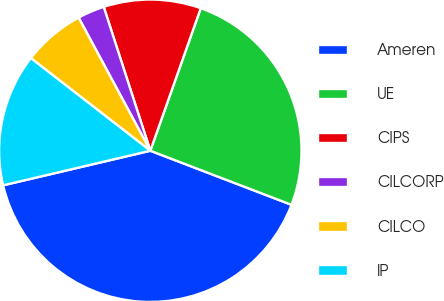Convert chart to OTSL. <chart><loc_0><loc_0><loc_500><loc_500><pie_chart><fcel>Ameren<fcel>UE<fcel>CIPS<fcel>CILCORP<fcel>CILCO<fcel>IP<nl><fcel>40.51%<fcel>25.41%<fcel>10.4%<fcel>2.88%<fcel>6.64%<fcel>14.17%<nl></chart> 